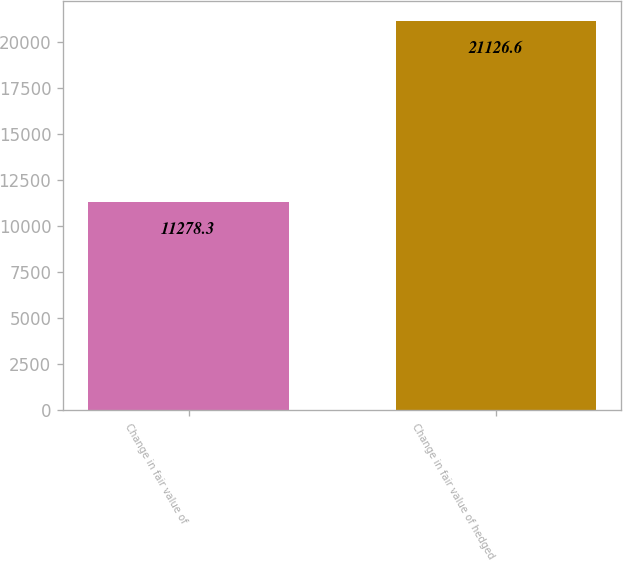Convert chart. <chart><loc_0><loc_0><loc_500><loc_500><bar_chart><fcel>Change in fair value of<fcel>Change in fair value of hedged<nl><fcel>11278.3<fcel>21126.6<nl></chart> 